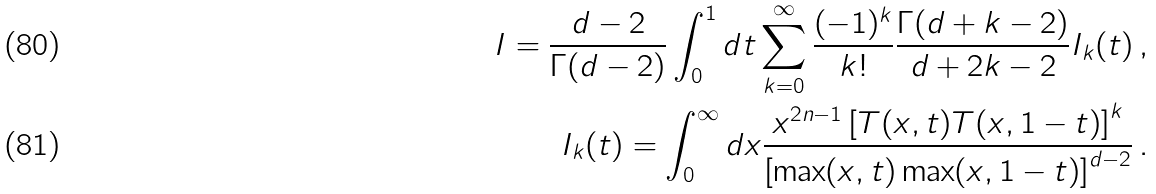Convert formula to latex. <formula><loc_0><loc_0><loc_500><loc_500>I = \frac { d - 2 } { \Gamma ( d - 2 ) } \int _ { 0 } ^ { 1 } d t \sum _ { k = 0 } ^ { \infty } \frac { ( - 1 ) ^ { k } } { k ! } \frac { \Gamma ( d + k - 2 ) } { d + 2 k - 2 } I _ { k } ( t ) \, , \\ I _ { k } ( t ) = \int _ { 0 } ^ { \infty } d x \frac { x ^ { 2 n - 1 } \left [ T ( x , t ) T ( x , 1 - t ) \right ] ^ { k } } { \left [ \max ( x , t ) \max ( x , 1 - t ) \right ] ^ { d - 2 } } \, .</formula> 